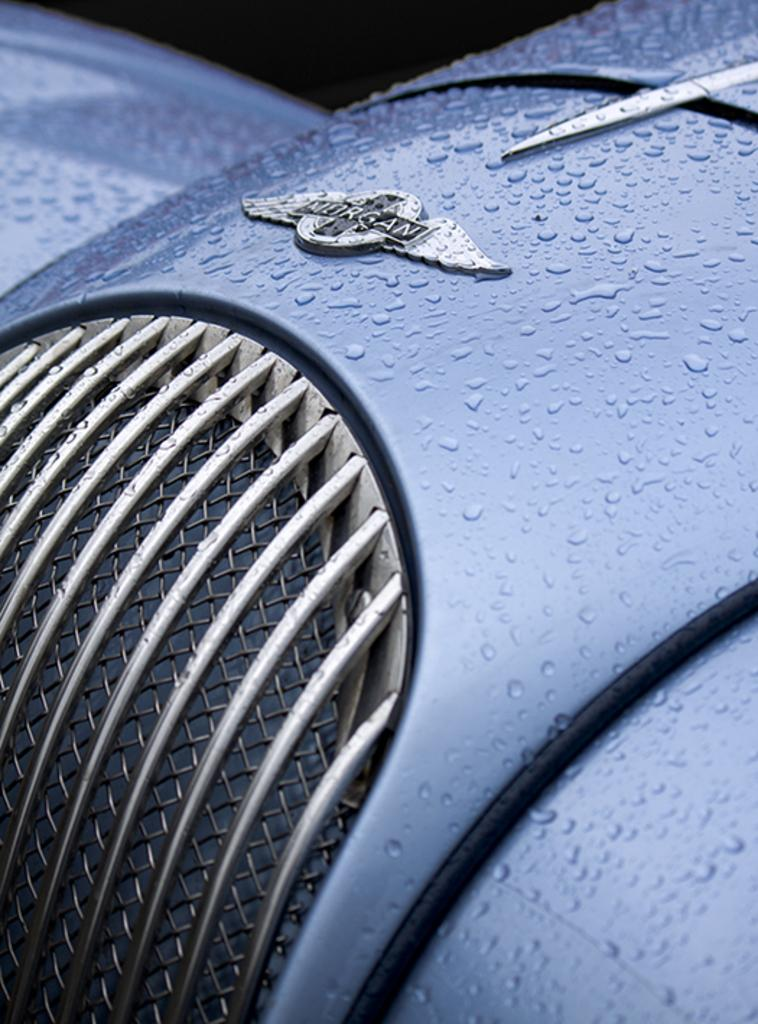What color is the object that can be seen in the image? The object in the image is blue. What can be found on the top side of the image? There is writing on the top side of the image. What type of noise can be heard coming from the blue object in the image? There is no indication of any noise coming from the blue object in the image. 